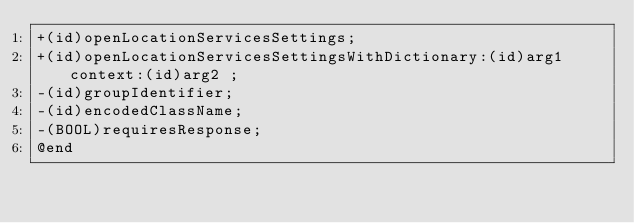<code> <loc_0><loc_0><loc_500><loc_500><_C_>+(id)openLocationServicesSettings;
+(id)openLocationServicesSettingsWithDictionary:(id)arg1 context:(id)arg2 ;
-(id)groupIdentifier;
-(id)encodedClassName;
-(BOOL)requiresResponse;
@end

</code> 